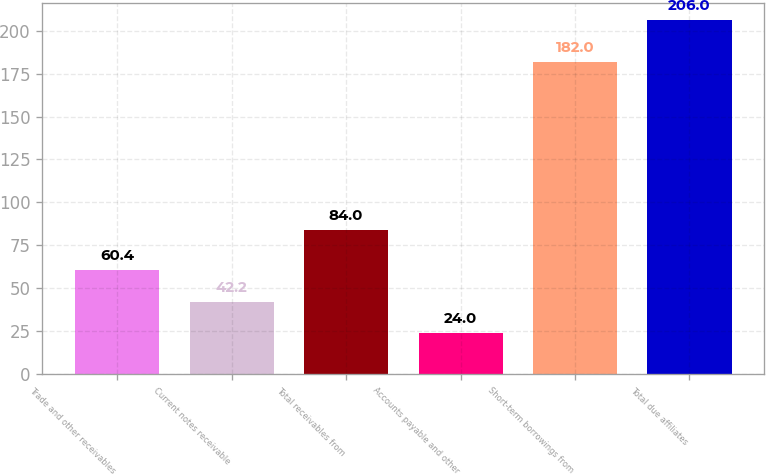Convert chart. <chart><loc_0><loc_0><loc_500><loc_500><bar_chart><fcel>Trade and other receivables<fcel>Current notes receivable<fcel>Total receivables from<fcel>Accounts payable and other<fcel>Short-term borrowings from<fcel>Total due affiliates<nl><fcel>60.4<fcel>42.2<fcel>84<fcel>24<fcel>182<fcel>206<nl></chart> 